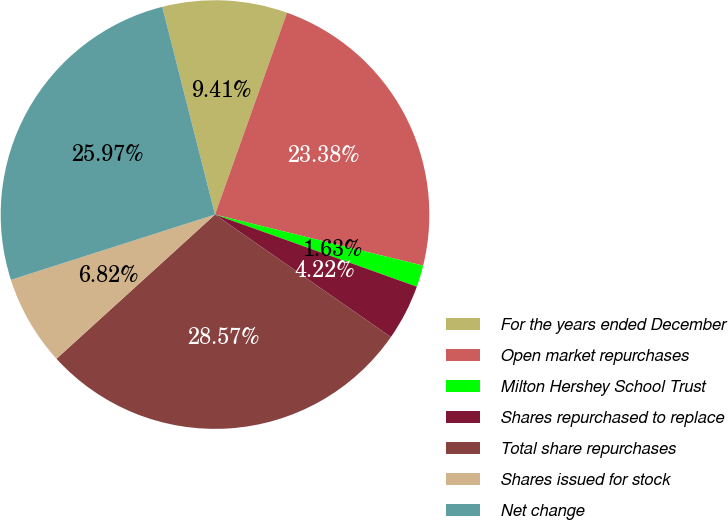Convert chart. <chart><loc_0><loc_0><loc_500><loc_500><pie_chart><fcel>For the years ended December<fcel>Open market repurchases<fcel>Milton Hershey School Trust<fcel>Shares repurchased to replace<fcel>Total share repurchases<fcel>Shares issued for stock<fcel>Net change<nl><fcel>9.41%<fcel>23.38%<fcel>1.63%<fcel>4.22%<fcel>28.57%<fcel>6.82%<fcel>25.97%<nl></chart> 